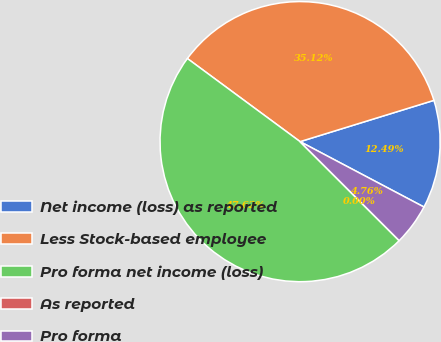<chart> <loc_0><loc_0><loc_500><loc_500><pie_chart><fcel>Net income (loss) as reported<fcel>Less Stock-based employee<fcel>Pro forma net income (loss)<fcel>As reported<fcel>Pro forma<nl><fcel>12.49%<fcel>35.12%<fcel>47.62%<fcel>0.0%<fcel>4.76%<nl></chart> 